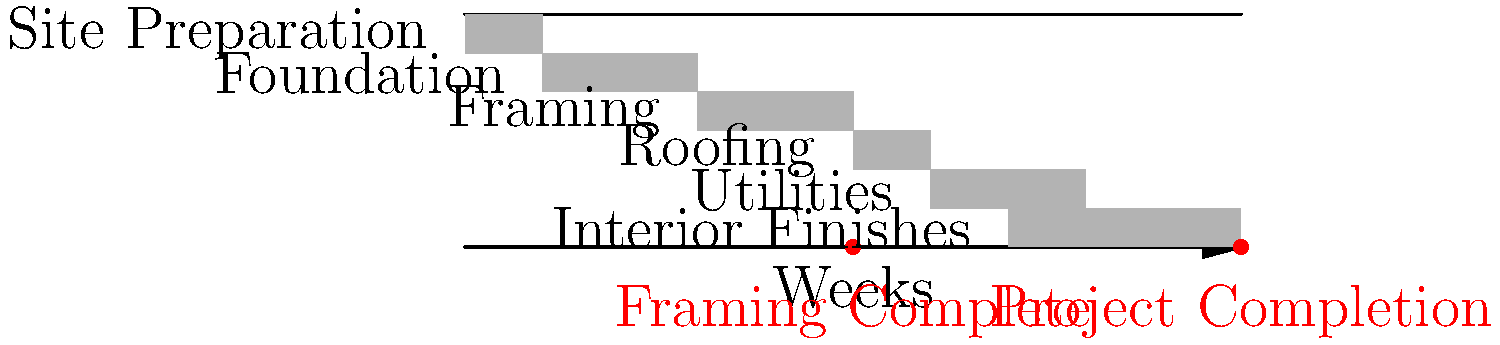Based on the Gantt chart for an affordable housing development project, what is the critical path duration, and which task is on the critical path that, if delayed, would most impact the project completion date? To determine the critical path and identify the task that would most impact the project completion date, let's analyze the Gantt chart step-by-step:

1. Identify all tasks and their durations:
   - Site Preparation: 2 weeks (weeks 0-2)
   - Foundation: 4 weeks (weeks 2-6)
   - Framing: 4 weeks (weeks 6-10)
   - Roofing: 2 weeks (weeks 10-12)
   - Utilities: 4 weeks (weeks 12-16)
   - Interior Finishes: 6 weeks (weeks 14-20)

2. Determine the project duration:
   The project starts at week 0 and ends at week 20, so the total duration is 20 weeks.

3. Identify the critical path:
   The critical path is the sequence of tasks that, if delayed, would delay the entire project. In this case, it's the path with no slack time between tasks:
   Site Preparation → Foundation → Framing → Roofing → Utilities → Interior Finishes

4. Calculate the critical path duration:
   Sum of durations: 2 + 4 + 4 + 2 + 4 + 6 = 22 weeks

5. Identify the task with the most impact:
   The task on the critical path with the longest duration is Interior Finishes (6 weeks). Any delay in this task would directly impact the project completion date by the same amount of time.

Therefore, the critical path duration is 22 weeks, and the task that would most impact the project completion date if delayed is Interior Finishes.
Answer: 22 weeks; Interior Finishes 